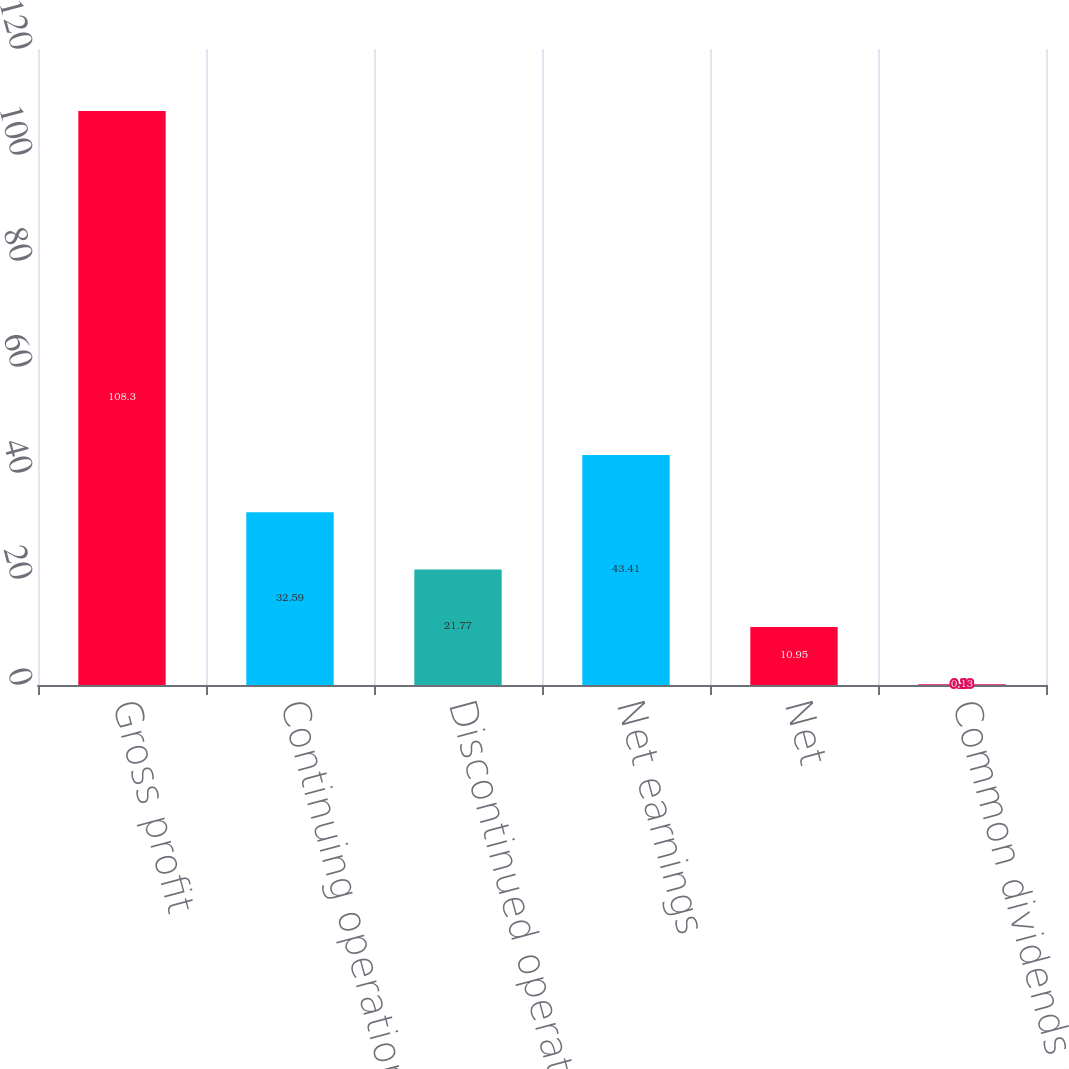<chart> <loc_0><loc_0><loc_500><loc_500><bar_chart><fcel>Gross profit<fcel>Continuing operations<fcel>Discontinued operations<fcel>Net earnings<fcel>Net<fcel>Common dividends declared<nl><fcel>108.3<fcel>32.59<fcel>21.77<fcel>43.41<fcel>10.95<fcel>0.13<nl></chart> 